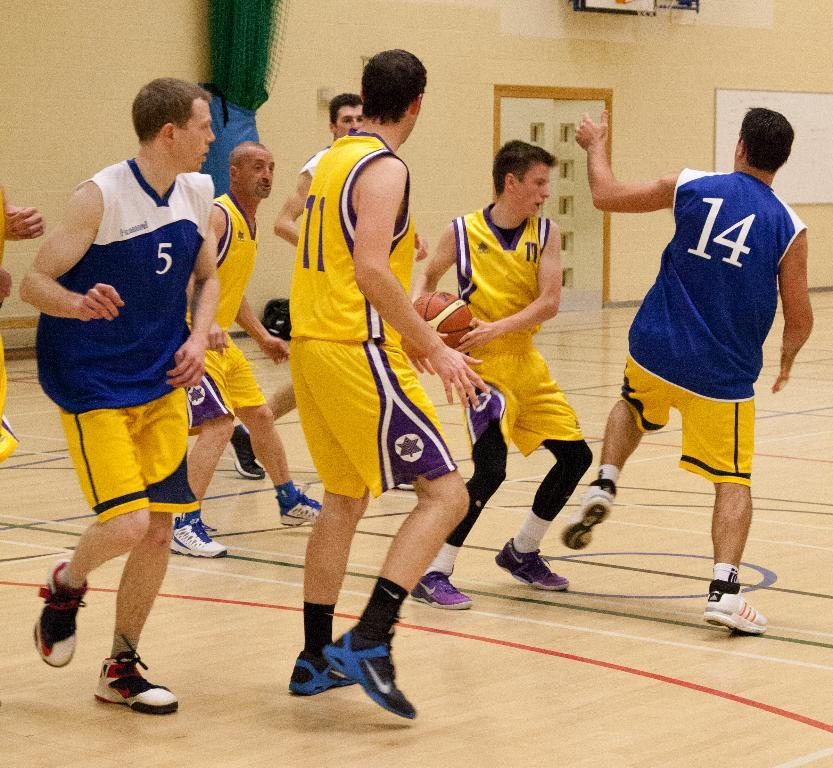Provide a one-sentence caption for the provided image. The basketball player in the number 17 jersey has the ball. 